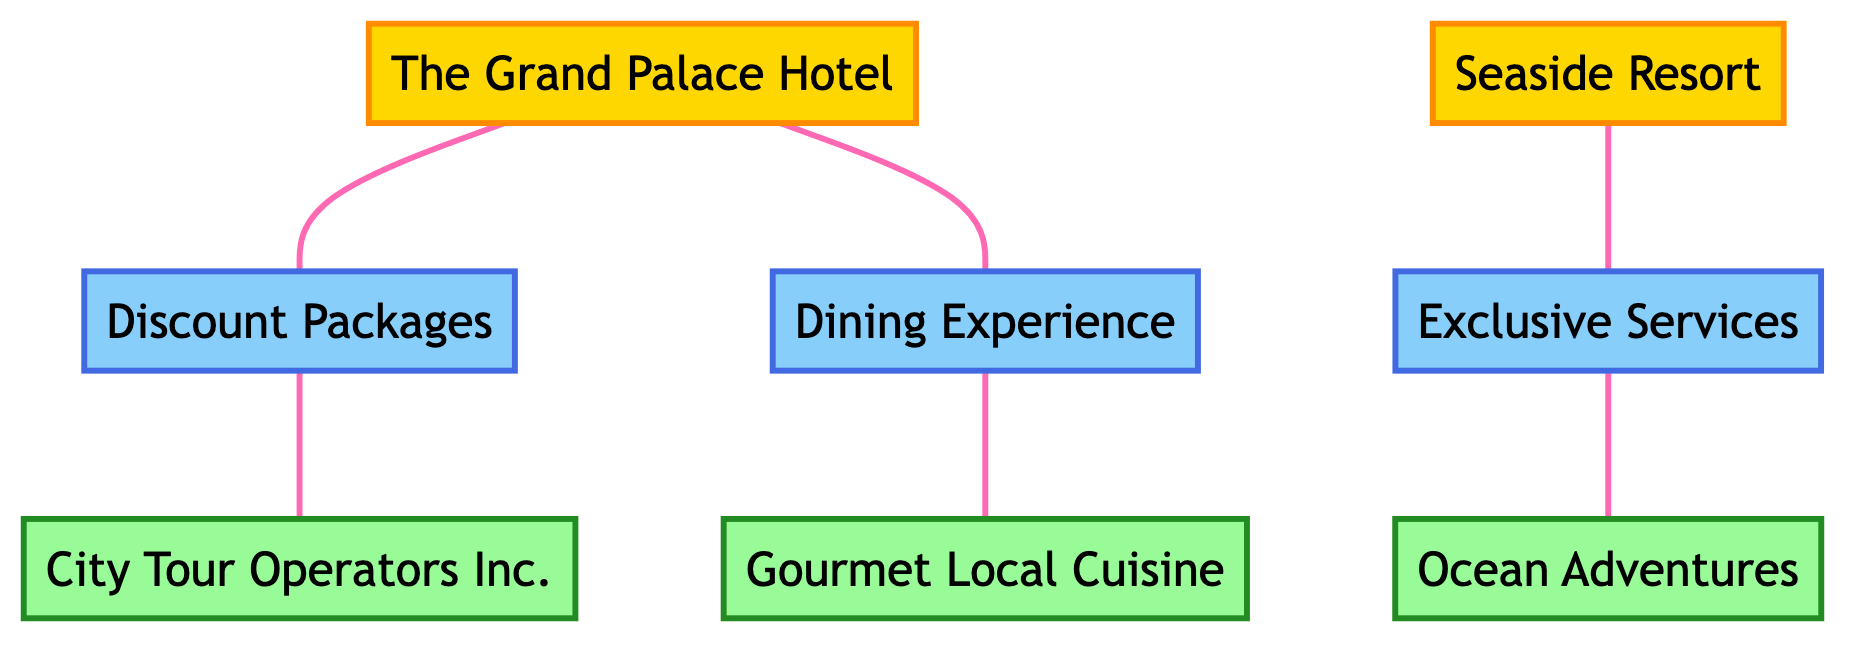What is the rating of The Grand Palace Hotel? The diagram indicates that The Grand Palace Hotel has a rating of 5.
Answer: 5 What type of service does Ocean Adventures provide? According to the diagram, Ocean Adventures offers Water Sports as their service type.
Answer: Water Sports How many partnerships are there in total? The diagram shows three partnerships: Discount Packages, Exclusive Services, and Dining Experience, thus totaling three.
Answer: 3 Which hotel has a partnership with City Tour Operators Inc.? By examining the connections in the diagram, it is clear that The Grand Palace Hotel is linked to City Tour Operators Inc. through the Discount Packages partnership.
Answer: The Grand Palace Hotel What is the partnership type between Seaside Resort and Ocean Adventures? The diagram specifies that the partnership type is Exclusive Services, as indicated by the link between Seaside Resort and Ocean Adventures.
Answer: Exclusive Services Which local business has a dining experience partnership with The Grand Palace Hotel? The diagram highlights that Gourmet Local Cuisine partners with The Grand Palace Hotel for a Dining Experience.
Answer: Gourmet Local Cuisine How many total rooms does Seaside Resort have? The diagram states that Seaside Resort has a total of 150 rooms.
Answer: 150 What is the service type of the business located in the City Center? The diagram reveals that there are two businesses in the City Center: City Tour Operators Inc. providing Sightseeing Tours and Gourmet Local Cuisine providing Dining. The question specifies a single service type; however, both are valid.
Answer: Sightseeing Tours or Dining Which partnership offers a discount to hotel guests? Analyzing the diagram, the Discount Packages partnership provides a 10% discount to guests at The Grand Palace Hotel for City Tour Operators Inc. services.
Answer: Discount Packages 